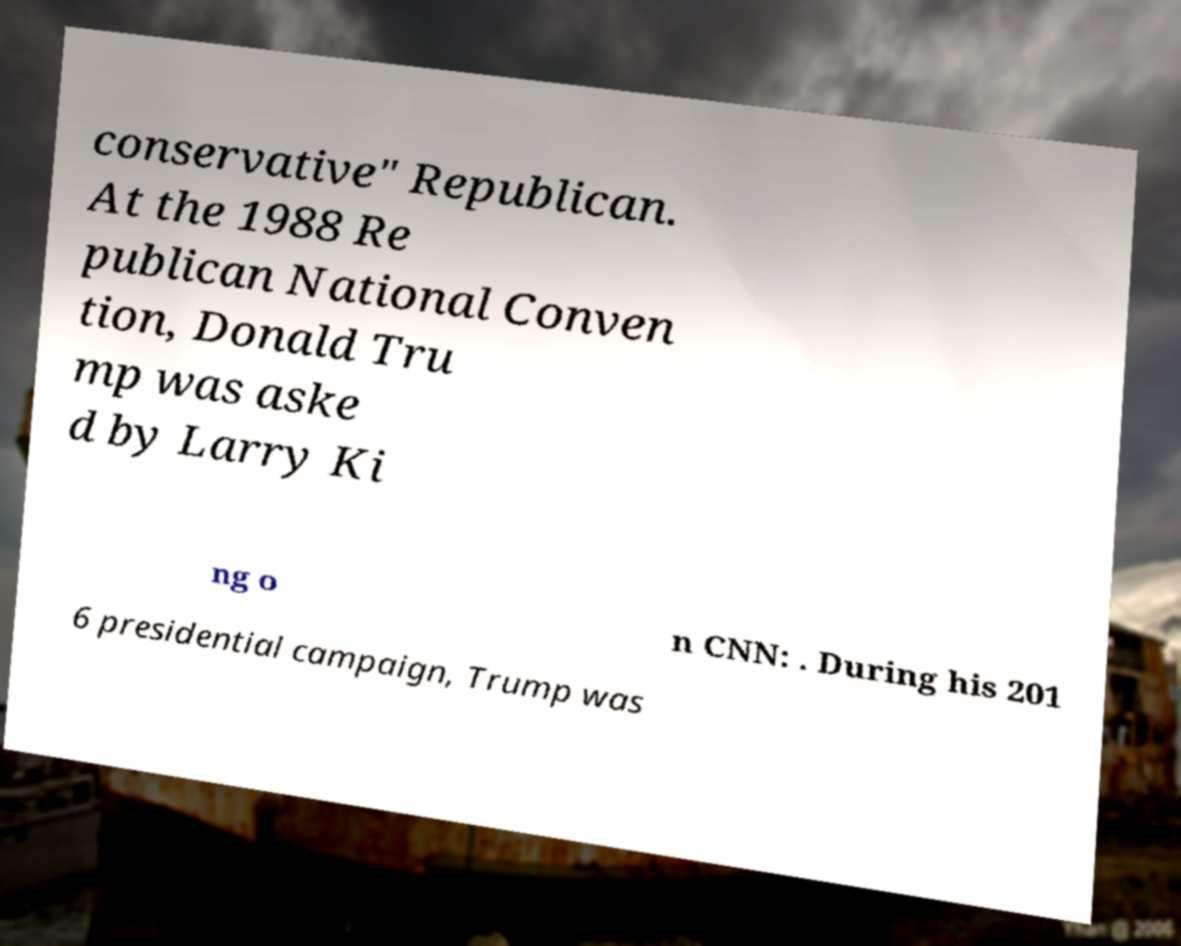For documentation purposes, I need the text within this image transcribed. Could you provide that? conservative" Republican. At the 1988 Re publican National Conven tion, Donald Tru mp was aske d by Larry Ki ng o n CNN: . During his 201 6 presidential campaign, Trump was 